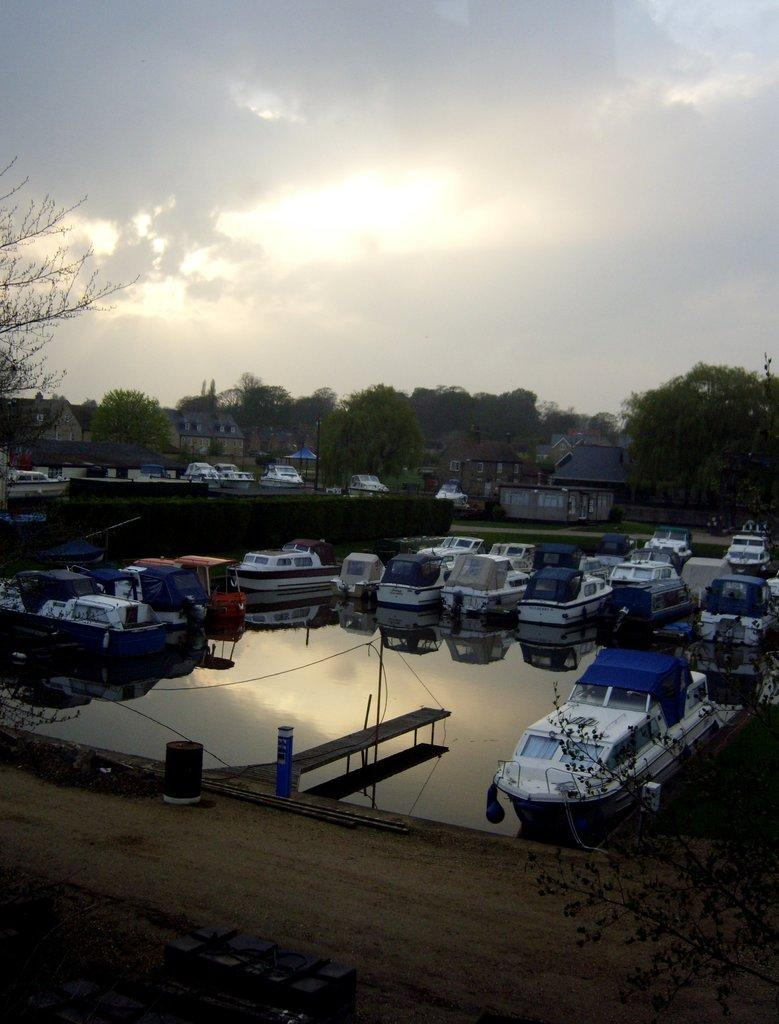What is the main subject of the image? The main subject of the image is a harbor. What can be seen in the harbor? There are white color boards in the harbor. How are the boards positioned in the harbor? The boards are parked on the water. What structure is visible in the front bottom of the image? There is a wooden bridge in the front bottom of the image. What type of vegetation can be seen in the background of the image? There are trees visible in the background of the image. What else is present in the background of the image? There are boats in the background of the image. What type of roof can be seen on the turkey in the image? There is no turkey present in the image, and therefore no roof can be seen on it. 